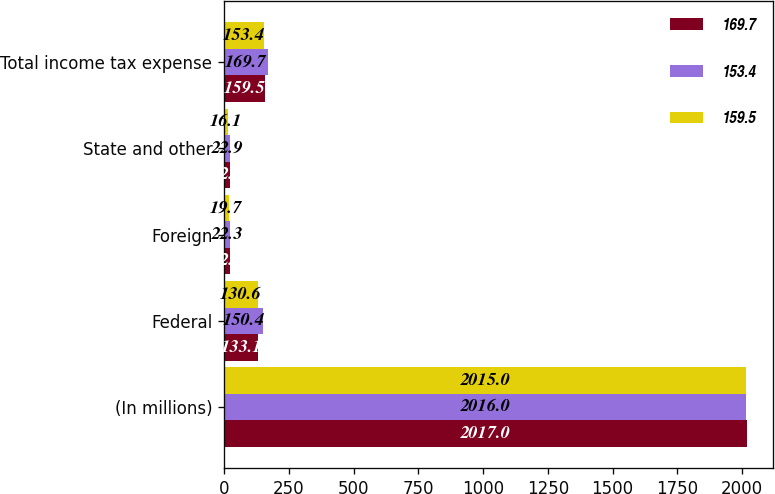<chart> <loc_0><loc_0><loc_500><loc_500><stacked_bar_chart><ecel><fcel>(In millions)<fcel>Federal<fcel>Foreign<fcel>State and other<fcel>Total income tax expense<nl><fcel>169.7<fcel>2017<fcel>133.1<fcel>22.4<fcel>22.8<fcel>159.5<nl><fcel>153.4<fcel>2016<fcel>150.4<fcel>22.3<fcel>22.9<fcel>169.7<nl><fcel>159.5<fcel>2015<fcel>130.6<fcel>19.7<fcel>16.1<fcel>153.4<nl></chart> 